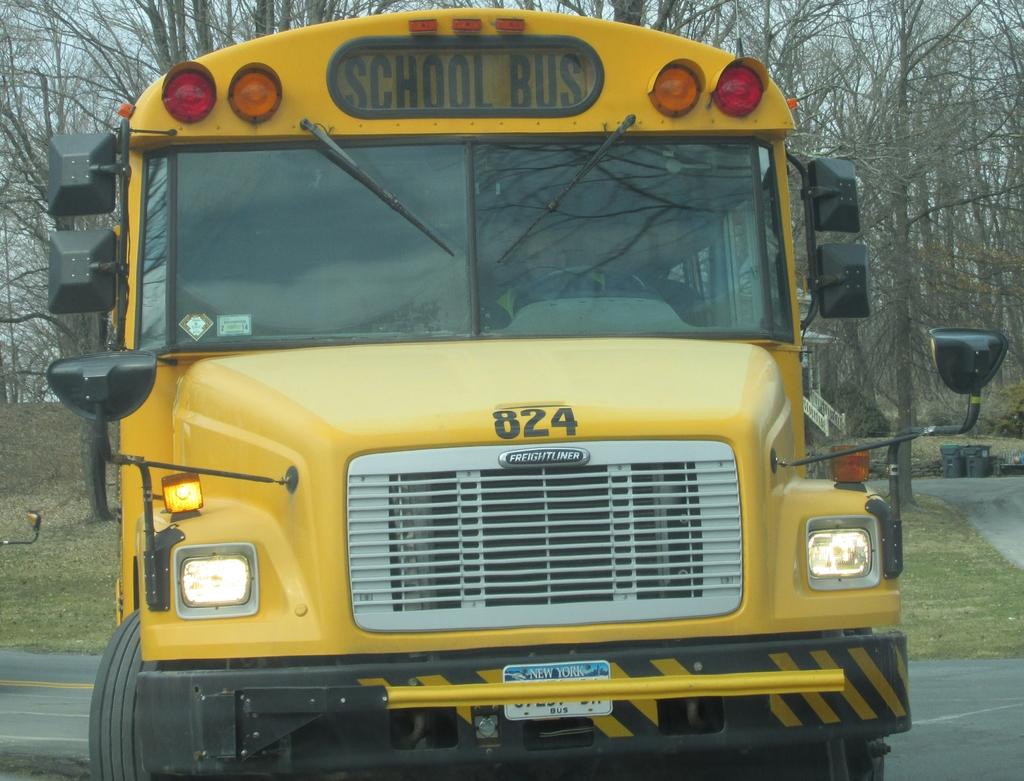What is the main subject in the center of the image? There is a school bus in the center of the image. What can be seen in the background of the image? There are trees in the background of the image. What type of oil is being transported by the school bus in the image? There is no indication of any oil or transportation of oil in the image; it features a school bus and trees in the background. 